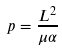Convert formula to latex. <formula><loc_0><loc_0><loc_500><loc_500>p = \frac { L ^ { 2 } } { \mu \alpha }</formula> 